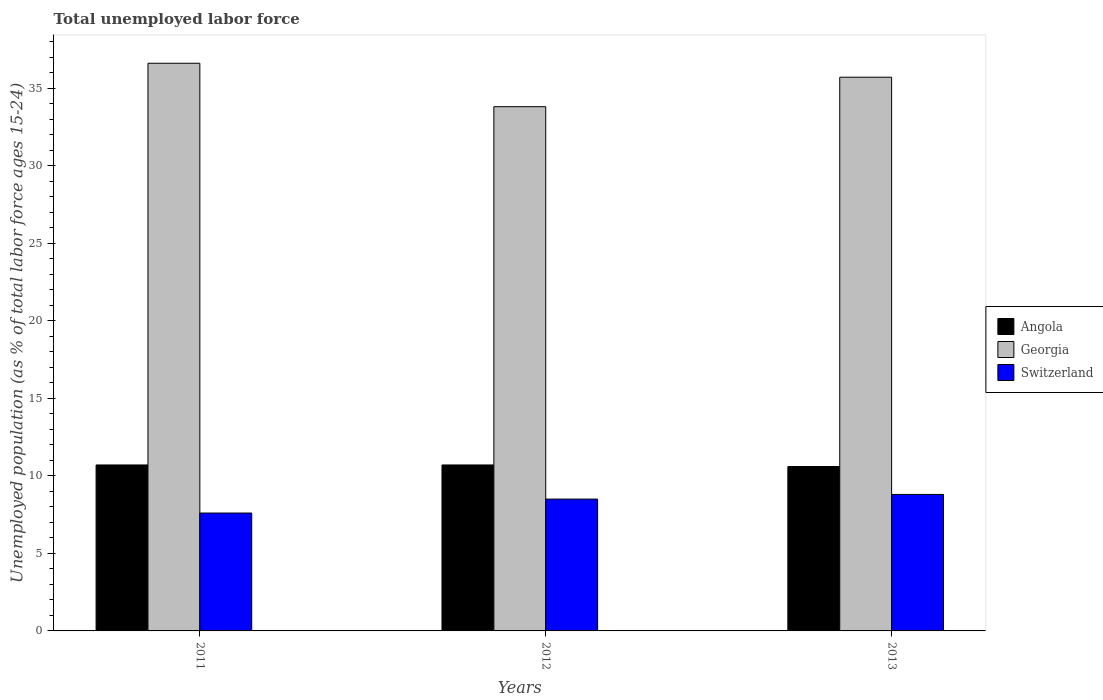How many different coloured bars are there?
Provide a succinct answer. 3. How many groups of bars are there?
Your response must be concise. 3. Are the number of bars per tick equal to the number of legend labels?
Give a very brief answer. Yes. Are the number of bars on each tick of the X-axis equal?
Your answer should be compact. Yes. How many bars are there on the 3rd tick from the left?
Your answer should be compact. 3. What is the label of the 1st group of bars from the left?
Provide a short and direct response. 2011. In how many cases, is the number of bars for a given year not equal to the number of legend labels?
Your answer should be very brief. 0. What is the percentage of unemployed population in in Georgia in 2011?
Give a very brief answer. 36.6. Across all years, what is the maximum percentage of unemployed population in in Switzerland?
Keep it short and to the point. 8.8. Across all years, what is the minimum percentage of unemployed population in in Georgia?
Provide a short and direct response. 33.8. In which year was the percentage of unemployed population in in Georgia maximum?
Keep it short and to the point. 2011. In which year was the percentage of unemployed population in in Switzerland minimum?
Ensure brevity in your answer.  2011. What is the total percentage of unemployed population in in Georgia in the graph?
Your answer should be compact. 106.1. What is the difference between the percentage of unemployed population in in Angola in 2012 and that in 2013?
Give a very brief answer. 0.1. What is the difference between the percentage of unemployed population in in Angola in 2011 and the percentage of unemployed population in in Georgia in 2012?
Make the answer very short. -23.1. What is the average percentage of unemployed population in in Switzerland per year?
Offer a terse response. 8.3. In the year 2011, what is the difference between the percentage of unemployed population in in Angola and percentage of unemployed population in in Georgia?
Provide a short and direct response. -25.9. What is the ratio of the percentage of unemployed population in in Georgia in 2012 to that in 2013?
Provide a succinct answer. 0.95. Is the difference between the percentage of unemployed population in in Angola in 2011 and 2012 greater than the difference between the percentage of unemployed population in in Georgia in 2011 and 2012?
Your answer should be compact. No. What is the difference between the highest and the second highest percentage of unemployed population in in Switzerland?
Your response must be concise. 0.3. What is the difference between the highest and the lowest percentage of unemployed population in in Angola?
Provide a short and direct response. 0.1. In how many years, is the percentage of unemployed population in in Angola greater than the average percentage of unemployed population in in Angola taken over all years?
Offer a terse response. 2. Is the sum of the percentage of unemployed population in in Angola in 2012 and 2013 greater than the maximum percentage of unemployed population in in Switzerland across all years?
Offer a very short reply. Yes. What does the 1st bar from the left in 2013 represents?
Keep it short and to the point. Angola. What does the 2nd bar from the right in 2011 represents?
Offer a very short reply. Georgia. How many bars are there?
Offer a very short reply. 9. How many years are there in the graph?
Make the answer very short. 3. What is the difference between two consecutive major ticks on the Y-axis?
Make the answer very short. 5. Are the values on the major ticks of Y-axis written in scientific E-notation?
Keep it short and to the point. No. Does the graph contain any zero values?
Provide a short and direct response. No. Does the graph contain grids?
Give a very brief answer. No. How many legend labels are there?
Your response must be concise. 3. What is the title of the graph?
Keep it short and to the point. Total unemployed labor force. What is the label or title of the Y-axis?
Your answer should be compact. Unemployed population (as % of total labor force ages 15-24). What is the Unemployed population (as % of total labor force ages 15-24) of Angola in 2011?
Offer a terse response. 10.7. What is the Unemployed population (as % of total labor force ages 15-24) in Georgia in 2011?
Your answer should be very brief. 36.6. What is the Unemployed population (as % of total labor force ages 15-24) of Switzerland in 2011?
Your answer should be very brief. 7.6. What is the Unemployed population (as % of total labor force ages 15-24) of Angola in 2012?
Ensure brevity in your answer.  10.7. What is the Unemployed population (as % of total labor force ages 15-24) in Georgia in 2012?
Your response must be concise. 33.8. What is the Unemployed population (as % of total labor force ages 15-24) in Angola in 2013?
Give a very brief answer. 10.6. What is the Unemployed population (as % of total labor force ages 15-24) in Georgia in 2013?
Give a very brief answer. 35.7. What is the Unemployed population (as % of total labor force ages 15-24) in Switzerland in 2013?
Provide a short and direct response. 8.8. Across all years, what is the maximum Unemployed population (as % of total labor force ages 15-24) of Angola?
Offer a very short reply. 10.7. Across all years, what is the maximum Unemployed population (as % of total labor force ages 15-24) in Georgia?
Keep it short and to the point. 36.6. Across all years, what is the maximum Unemployed population (as % of total labor force ages 15-24) of Switzerland?
Keep it short and to the point. 8.8. Across all years, what is the minimum Unemployed population (as % of total labor force ages 15-24) in Angola?
Offer a very short reply. 10.6. Across all years, what is the minimum Unemployed population (as % of total labor force ages 15-24) of Georgia?
Offer a terse response. 33.8. Across all years, what is the minimum Unemployed population (as % of total labor force ages 15-24) of Switzerland?
Keep it short and to the point. 7.6. What is the total Unemployed population (as % of total labor force ages 15-24) in Angola in the graph?
Your answer should be very brief. 32. What is the total Unemployed population (as % of total labor force ages 15-24) of Georgia in the graph?
Your response must be concise. 106.1. What is the total Unemployed population (as % of total labor force ages 15-24) in Switzerland in the graph?
Give a very brief answer. 24.9. What is the difference between the Unemployed population (as % of total labor force ages 15-24) in Angola in 2011 and that in 2012?
Ensure brevity in your answer.  0. What is the difference between the Unemployed population (as % of total labor force ages 15-24) of Georgia in 2011 and that in 2013?
Your answer should be very brief. 0.9. What is the difference between the Unemployed population (as % of total labor force ages 15-24) of Switzerland in 2011 and that in 2013?
Your answer should be compact. -1.2. What is the difference between the Unemployed population (as % of total labor force ages 15-24) in Angola in 2012 and that in 2013?
Offer a very short reply. 0.1. What is the difference between the Unemployed population (as % of total labor force ages 15-24) in Switzerland in 2012 and that in 2013?
Your answer should be compact. -0.3. What is the difference between the Unemployed population (as % of total labor force ages 15-24) in Angola in 2011 and the Unemployed population (as % of total labor force ages 15-24) in Georgia in 2012?
Offer a terse response. -23.1. What is the difference between the Unemployed population (as % of total labor force ages 15-24) in Angola in 2011 and the Unemployed population (as % of total labor force ages 15-24) in Switzerland in 2012?
Offer a terse response. 2.2. What is the difference between the Unemployed population (as % of total labor force ages 15-24) of Georgia in 2011 and the Unemployed population (as % of total labor force ages 15-24) of Switzerland in 2012?
Ensure brevity in your answer.  28.1. What is the difference between the Unemployed population (as % of total labor force ages 15-24) in Georgia in 2011 and the Unemployed population (as % of total labor force ages 15-24) in Switzerland in 2013?
Your answer should be very brief. 27.8. What is the average Unemployed population (as % of total labor force ages 15-24) in Angola per year?
Your answer should be very brief. 10.67. What is the average Unemployed population (as % of total labor force ages 15-24) in Georgia per year?
Provide a short and direct response. 35.37. In the year 2011, what is the difference between the Unemployed population (as % of total labor force ages 15-24) of Angola and Unemployed population (as % of total labor force ages 15-24) of Georgia?
Provide a succinct answer. -25.9. In the year 2012, what is the difference between the Unemployed population (as % of total labor force ages 15-24) in Angola and Unemployed population (as % of total labor force ages 15-24) in Georgia?
Offer a terse response. -23.1. In the year 2012, what is the difference between the Unemployed population (as % of total labor force ages 15-24) in Angola and Unemployed population (as % of total labor force ages 15-24) in Switzerland?
Make the answer very short. 2.2. In the year 2012, what is the difference between the Unemployed population (as % of total labor force ages 15-24) of Georgia and Unemployed population (as % of total labor force ages 15-24) of Switzerland?
Offer a very short reply. 25.3. In the year 2013, what is the difference between the Unemployed population (as % of total labor force ages 15-24) of Angola and Unemployed population (as % of total labor force ages 15-24) of Georgia?
Offer a very short reply. -25.1. In the year 2013, what is the difference between the Unemployed population (as % of total labor force ages 15-24) of Georgia and Unemployed population (as % of total labor force ages 15-24) of Switzerland?
Make the answer very short. 26.9. What is the ratio of the Unemployed population (as % of total labor force ages 15-24) in Angola in 2011 to that in 2012?
Provide a short and direct response. 1. What is the ratio of the Unemployed population (as % of total labor force ages 15-24) in Georgia in 2011 to that in 2012?
Your response must be concise. 1.08. What is the ratio of the Unemployed population (as % of total labor force ages 15-24) of Switzerland in 2011 to that in 2012?
Offer a very short reply. 0.89. What is the ratio of the Unemployed population (as % of total labor force ages 15-24) in Angola in 2011 to that in 2013?
Your answer should be very brief. 1.01. What is the ratio of the Unemployed population (as % of total labor force ages 15-24) in Georgia in 2011 to that in 2013?
Offer a very short reply. 1.03. What is the ratio of the Unemployed population (as % of total labor force ages 15-24) of Switzerland in 2011 to that in 2013?
Your answer should be very brief. 0.86. What is the ratio of the Unemployed population (as % of total labor force ages 15-24) of Angola in 2012 to that in 2013?
Your response must be concise. 1.01. What is the ratio of the Unemployed population (as % of total labor force ages 15-24) in Georgia in 2012 to that in 2013?
Your answer should be compact. 0.95. What is the ratio of the Unemployed population (as % of total labor force ages 15-24) of Switzerland in 2012 to that in 2013?
Your answer should be very brief. 0.97. What is the difference between the highest and the second highest Unemployed population (as % of total labor force ages 15-24) of Georgia?
Offer a terse response. 0.9. What is the difference between the highest and the lowest Unemployed population (as % of total labor force ages 15-24) in Georgia?
Keep it short and to the point. 2.8. What is the difference between the highest and the lowest Unemployed population (as % of total labor force ages 15-24) of Switzerland?
Your response must be concise. 1.2. 